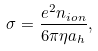<formula> <loc_0><loc_0><loc_500><loc_500>\sigma = \frac { e ^ { 2 } n _ { i o n } } { 6 \pi \eta a _ { h } } ,</formula> 